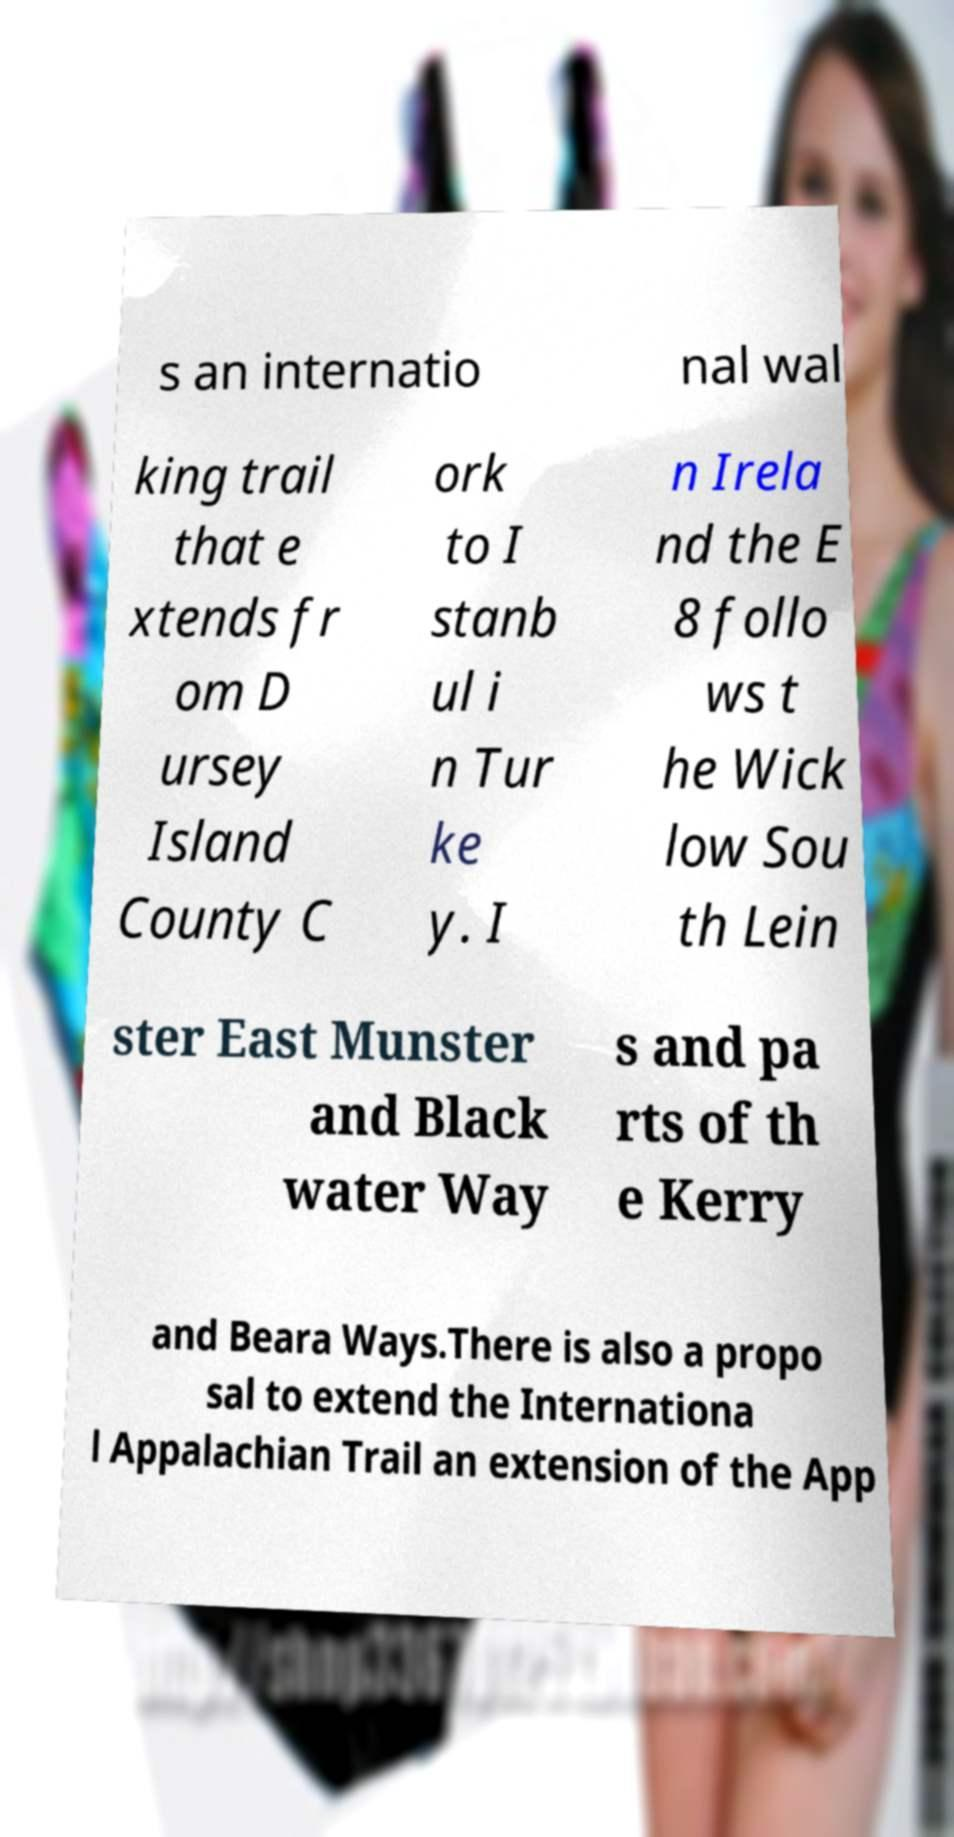Could you extract and type out the text from this image? s an internatio nal wal king trail that e xtends fr om D ursey Island County C ork to I stanb ul i n Tur ke y. I n Irela nd the E 8 follo ws t he Wick low Sou th Lein ster East Munster and Black water Way s and pa rts of th e Kerry and Beara Ways.There is also a propo sal to extend the Internationa l Appalachian Trail an extension of the App 